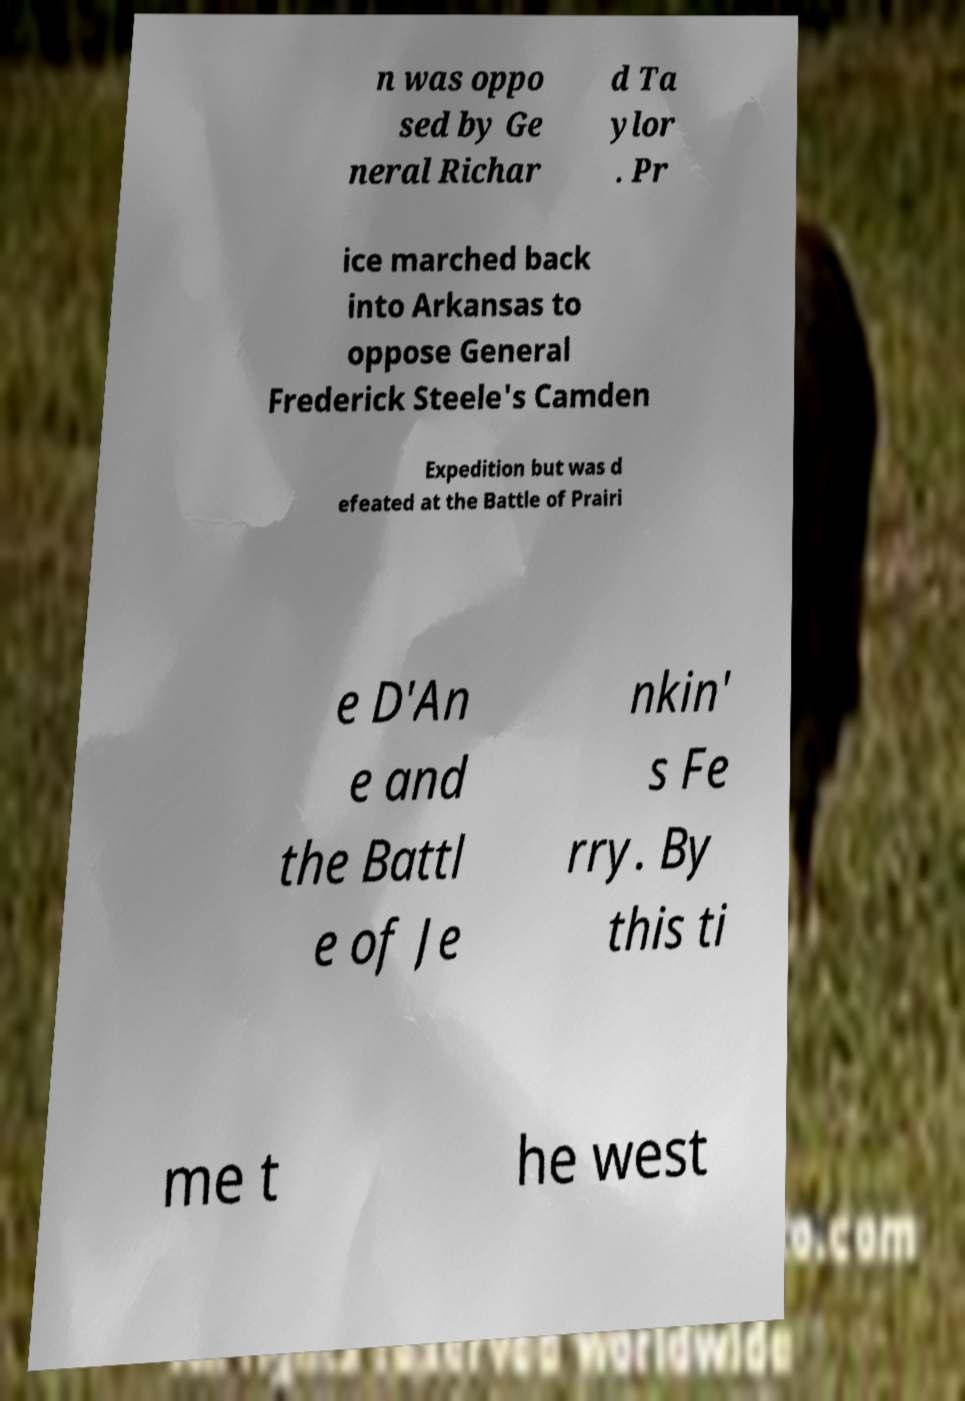What messages or text are displayed in this image? I need them in a readable, typed format. n was oppo sed by Ge neral Richar d Ta ylor . Pr ice marched back into Arkansas to oppose General Frederick Steele's Camden Expedition but was d efeated at the Battle of Prairi e D'An e and the Battl e of Je nkin' s Fe rry. By this ti me t he west 